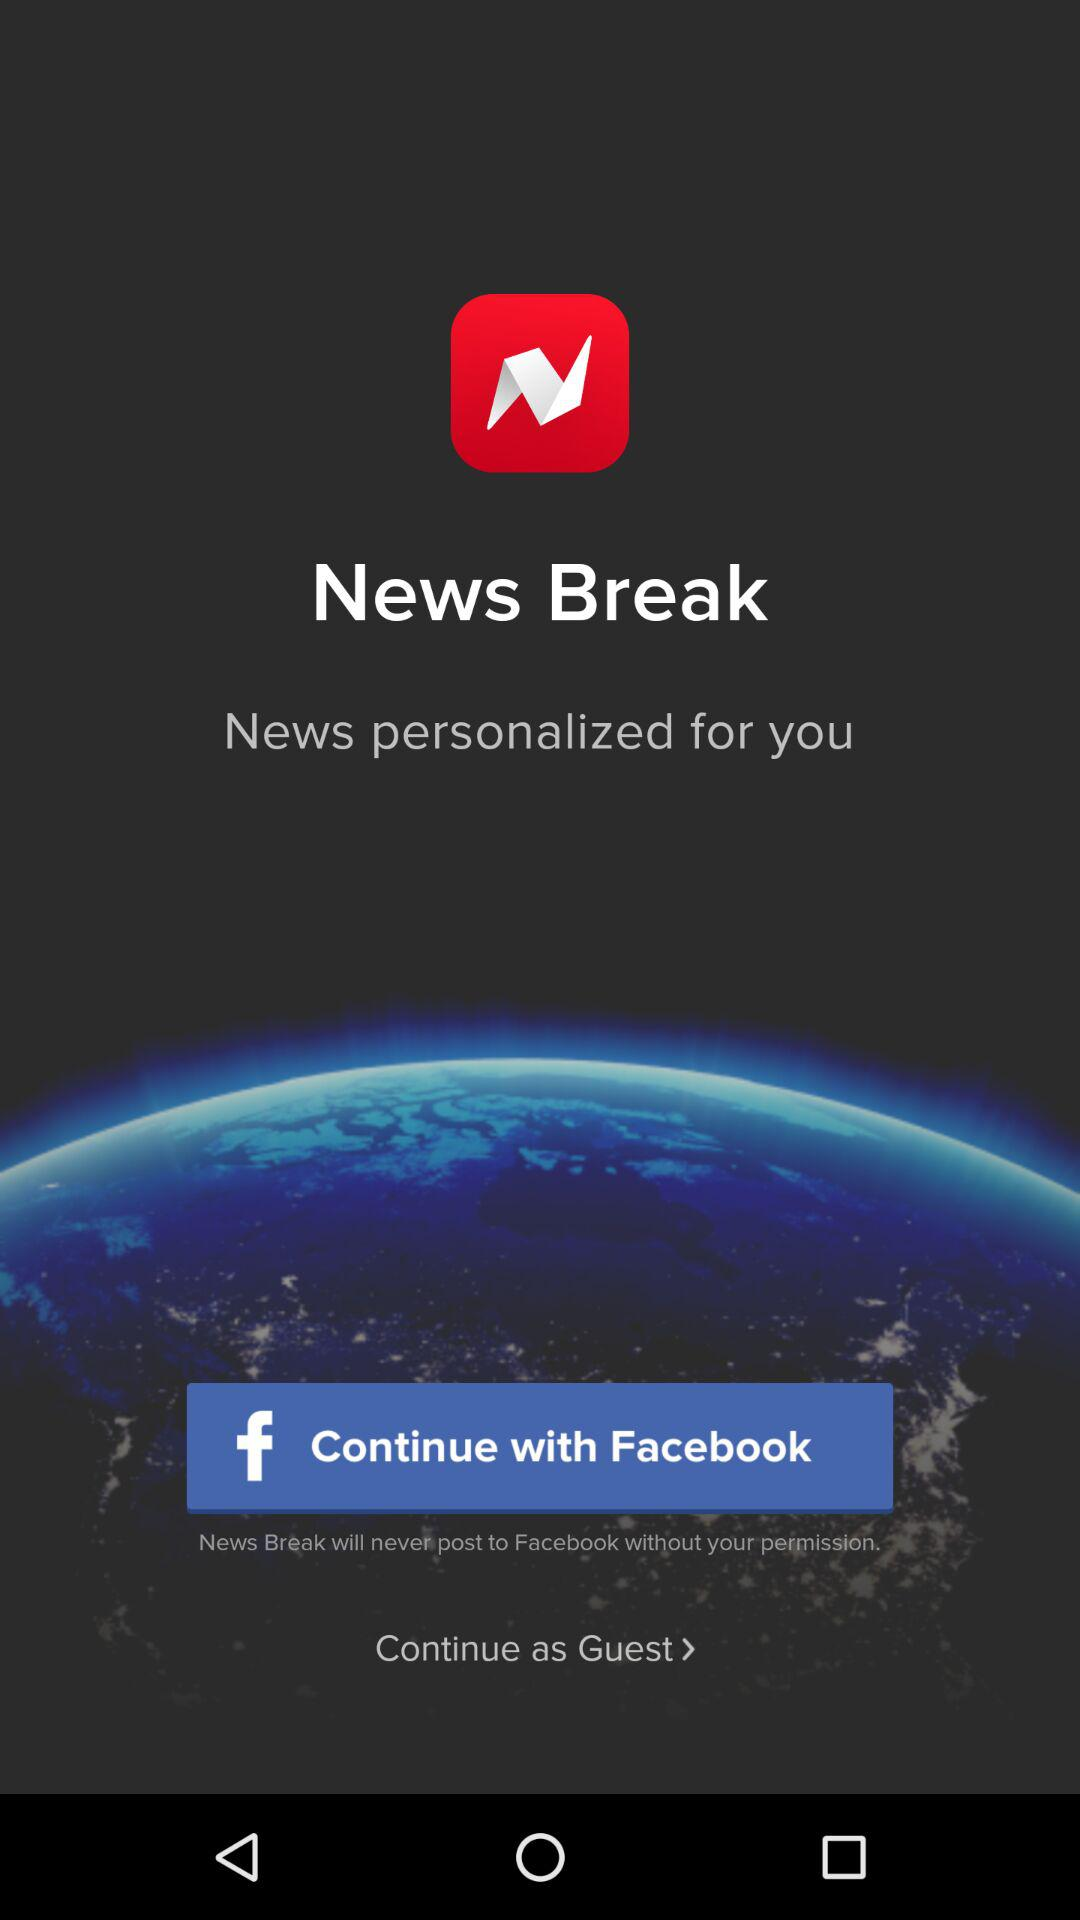What accounts can I use to sign in? You can use "Facebook" account to sign in. 